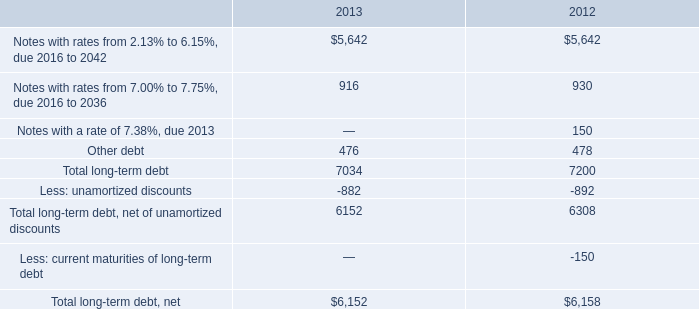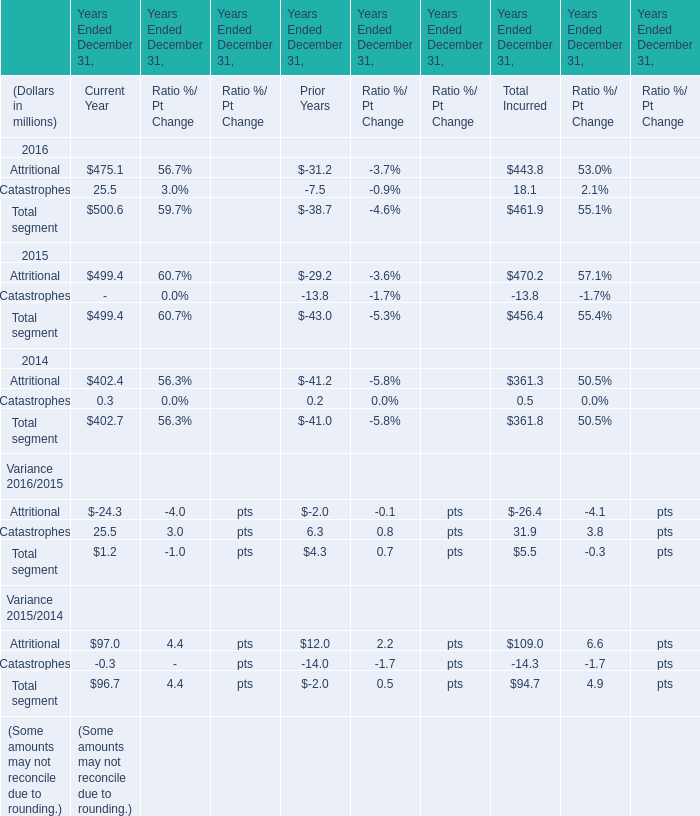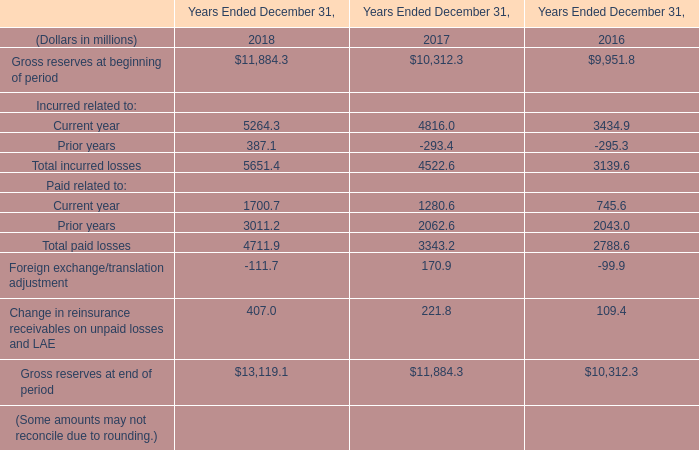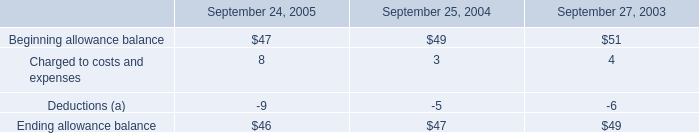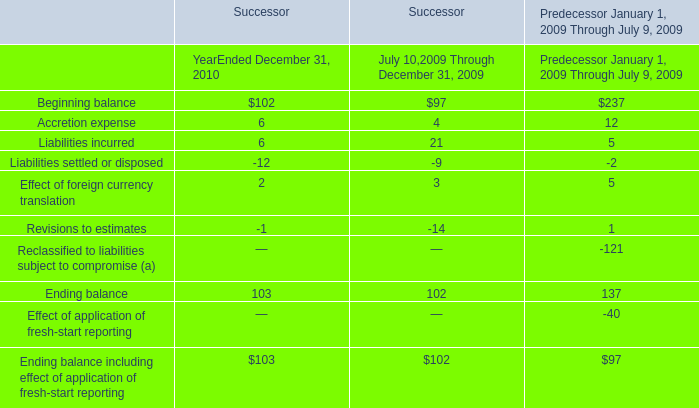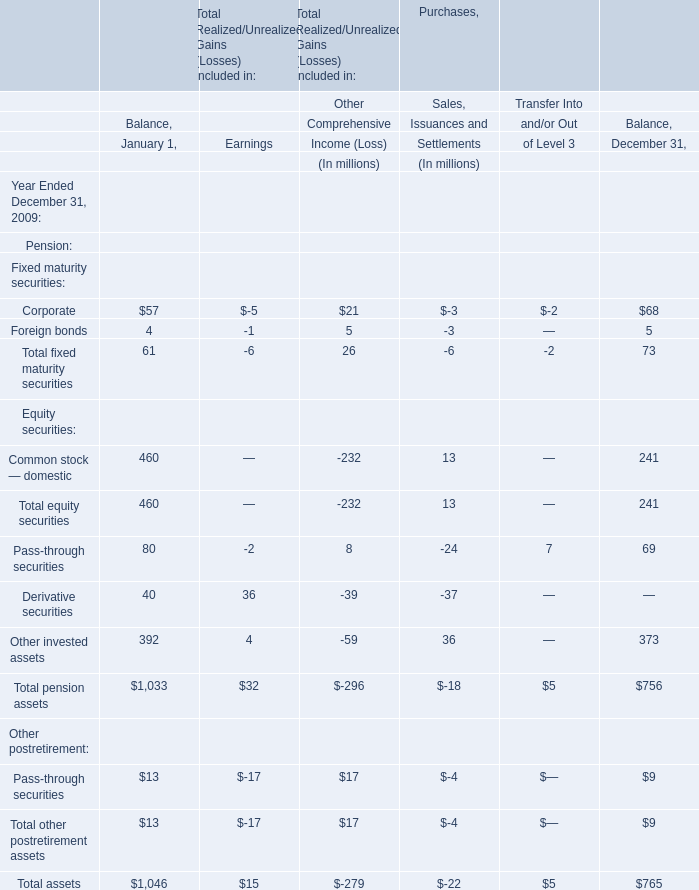What was the total amount of Attritional greater than 1 in 2016? (in million) 
Computations: (475.1 + 443.8)
Answer: 918.9. 